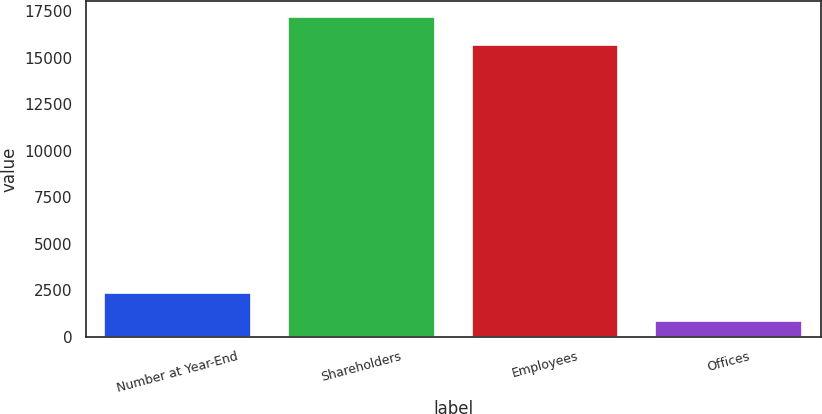Convert chart. <chart><loc_0><loc_0><loc_500><loc_500><bar_chart><fcel>Number at Year-End<fcel>Shareholders<fcel>Employees<fcel>Offices<nl><fcel>2360<fcel>17177<fcel>15666<fcel>849<nl></chart> 